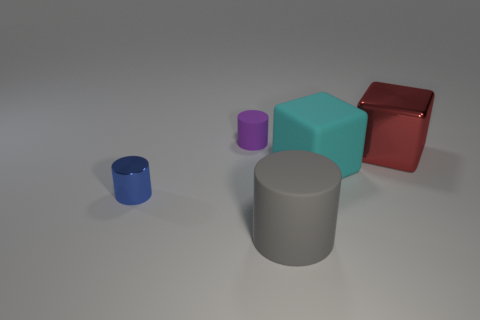Add 4 small red shiny cylinders. How many objects exist? 9 Subtract all cyan cubes. How many cubes are left? 1 Subtract all large gray cylinders. How many cylinders are left? 2 Subtract all purple cylinders. Subtract all cyan spheres. How many cylinders are left? 2 Subtract all red blocks. How many purple cylinders are left? 1 Subtract all large blue metallic objects. Subtract all large matte things. How many objects are left? 3 Add 1 tiny purple things. How many tiny purple things are left? 2 Add 4 metal things. How many metal things exist? 6 Subtract 0 purple cubes. How many objects are left? 5 Subtract all cylinders. How many objects are left? 2 